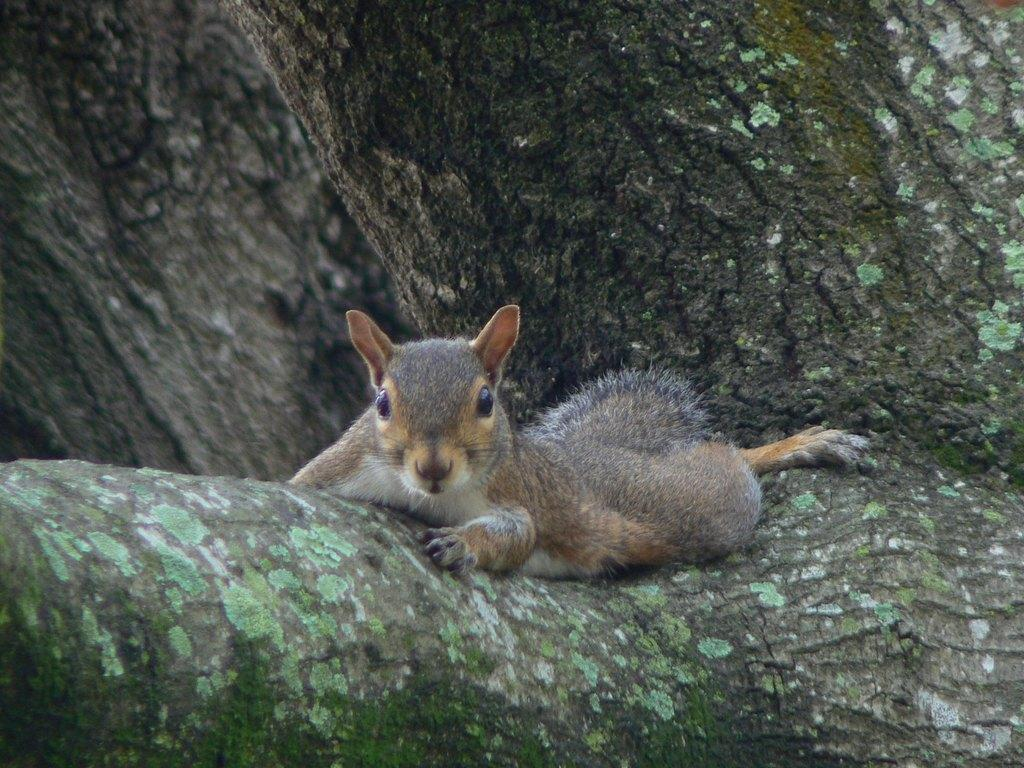What type of animal is in the image? There is a squirrel in the image. What is the squirrel doing in the image? The squirrel is laying on a branch. What is the branch a part of? The branch is part of a tree. Can you describe the tree in the image? There is a tree in the background of the image. How does the squirrel use its mouth to protect itself from the earthquake in the image? There is no earthquake present in the image, and the squirrel is not using its mouth for protection. 